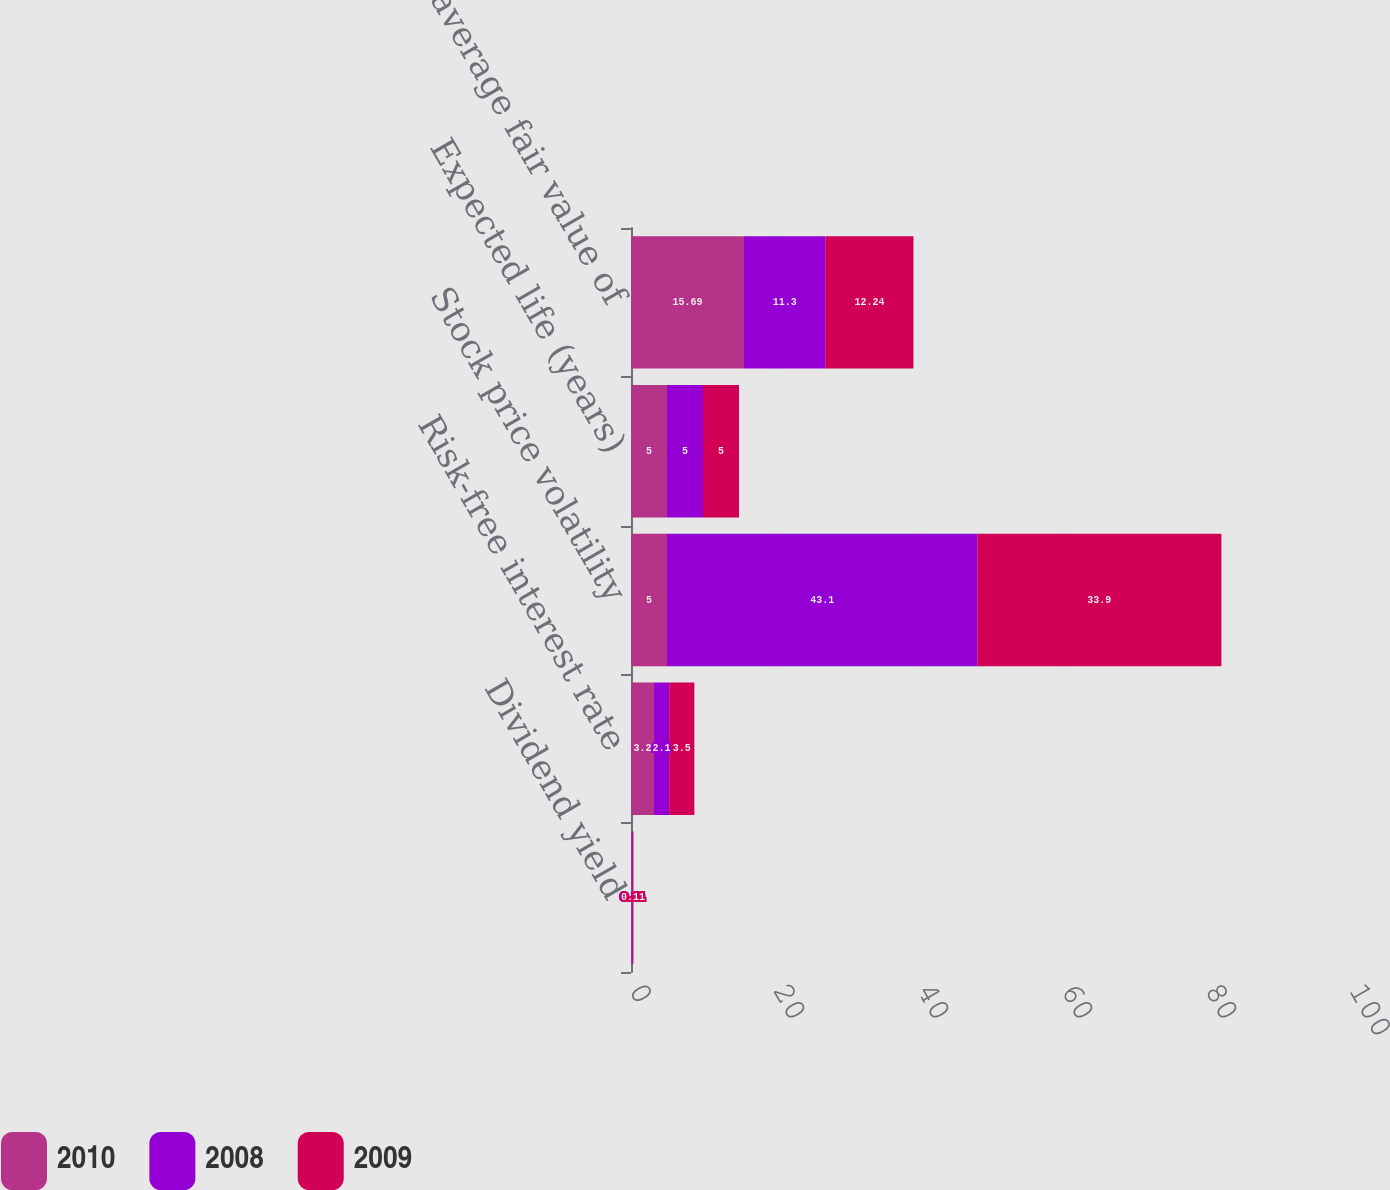Convert chart. <chart><loc_0><loc_0><loc_500><loc_500><stacked_bar_chart><ecel><fcel>Dividend yield<fcel>Risk-free interest rate<fcel>Stock price volatility<fcel>Expected life (years)<fcel>Weighted average fair value of<nl><fcel>2010<fcel>0.1<fcel>3.2<fcel>5<fcel>5<fcel>15.69<nl><fcel>2008<fcel>0.13<fcel>2.1<fcel>43.1<fcel>5<fcel>11.3<nl><fcel>2009<fcel>0.11<fcel>3.5<fcel>33.9<fcel>5<fcel>12.24<nl></chart> 